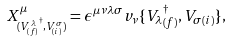Convert formula to latex. <formula><loc_0><loc_0><loc_500><loc_500>X ^ { \mu } _ { ( { V ^ { \lambda } _ { ( f ) } } ^ { \dag } , V ^ { \sigma } _ { ( i ) } ) } = \epsilon ^ { \mu \nu \lambda \sigma } v _ { \nu } \{ { V _ { \lambda } } _ { ( f ) } ^ { \dag } , { V _ { \sigma } } _ { ( i ) } \} ,</formula> 